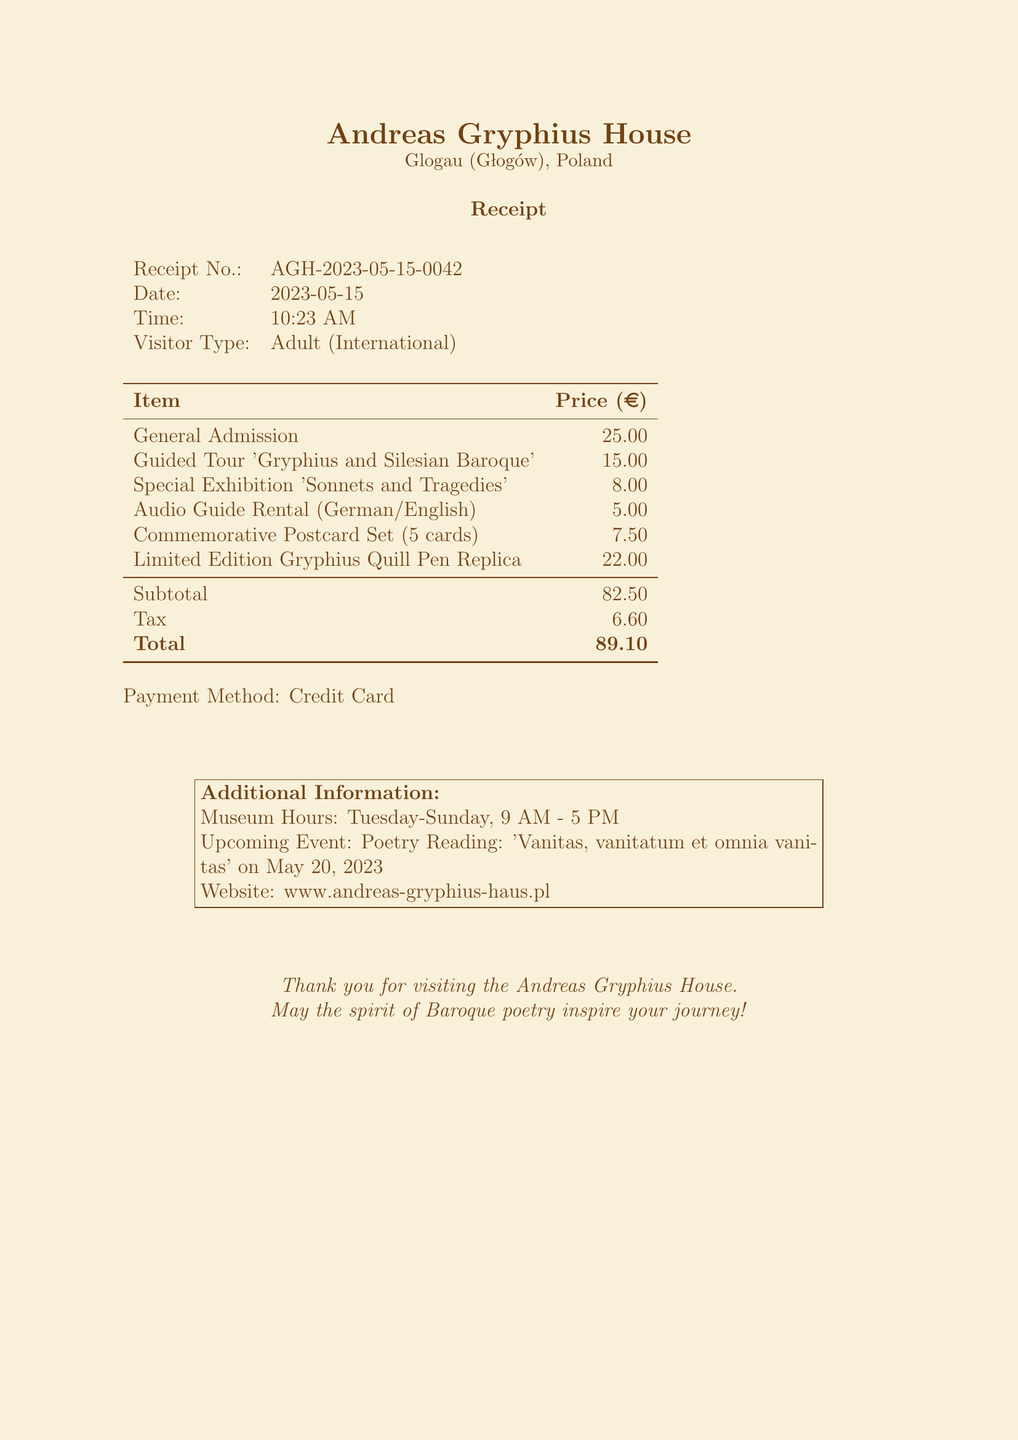What is the receipt number? The receipt number is clearly labeled in the document under "Receipt No."
Answer: AGH-2023-05-15-0042 What is the date of the museum visit? The date can be found next to the "Date" label on the receipt.
Answer: 2023-05-15 How much does general admission cost? The cost of general admission is listed in the itemized fees.
Answer: 25.00 What is the subtotal amount before tax? The subtotal is stated just before the tax in the summary of fees.
Answer: 82.50 What type of payment was used? The payment method is indicated near the bottom of the receipt.
Answer: Credit Card What is the price of the Guided Tour? The price is specified in the itemized list of charges.
Answer: 15.00 How much is the tax amount? The tax amount is shown in the summary just above the total.
Answer: 6.60 What is the total cost after tax? The total cost is the final amount shown in the summary of charges.
Answer: 89.10 What event is happening on May 20, 2023? The upcoming event is mentioned in the additional information section of the receipt.
Answer: Poetry Reading: 'Vanitas, vanitatum et omnia vanitas' 